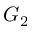<formula> <loc_0><loc_0><loc_500><loc_500>G _ { 2 }</formula> 